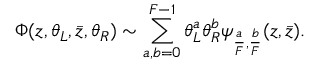<formula> <loc_0><loc_0><loc_500><loc_500>\Phi ( z , \theta _ { L } , \bar { z } , \theta _ { R } ) \sim \sum _ { a , b = 0 } ^ { F - 1 } \theta _ { L } ^ { a } \theta _ { R } ^ { b } \psi _ { { \frac { a } { F } } , { \frac { b } { F } } } ( z , { \bar { z } } ) .</formula> 